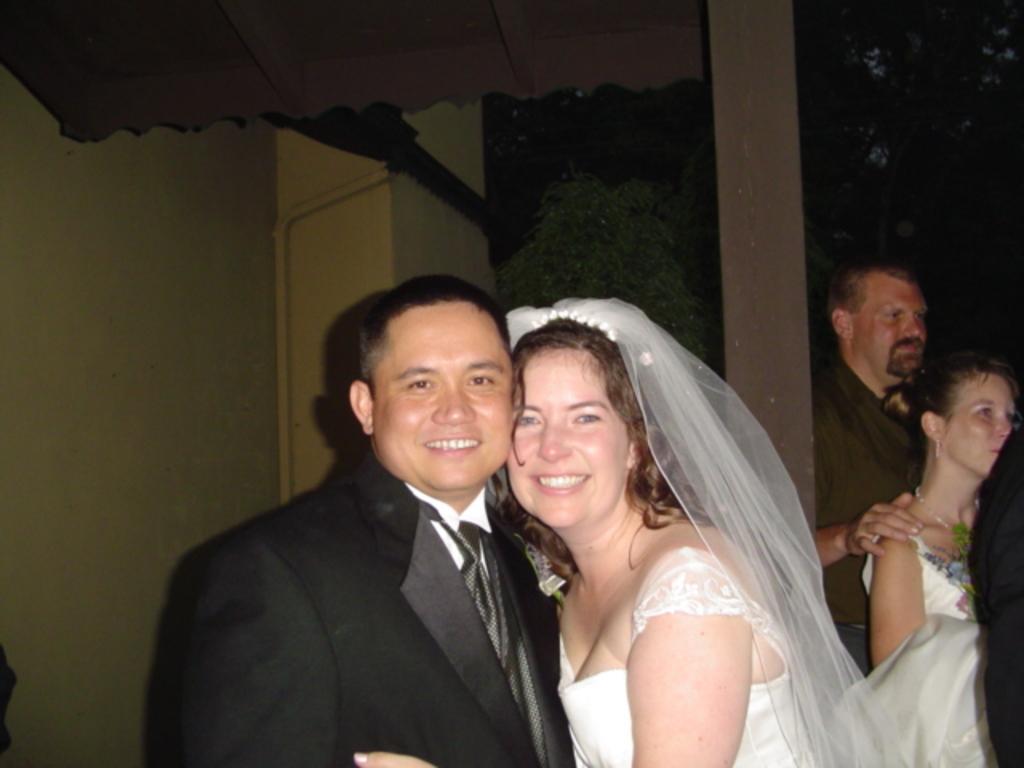How would you summarize this image in a sentence or two? In this picture we can see a bride and a groom smiling and looking at someone. Behind them there are 2 people standing. 